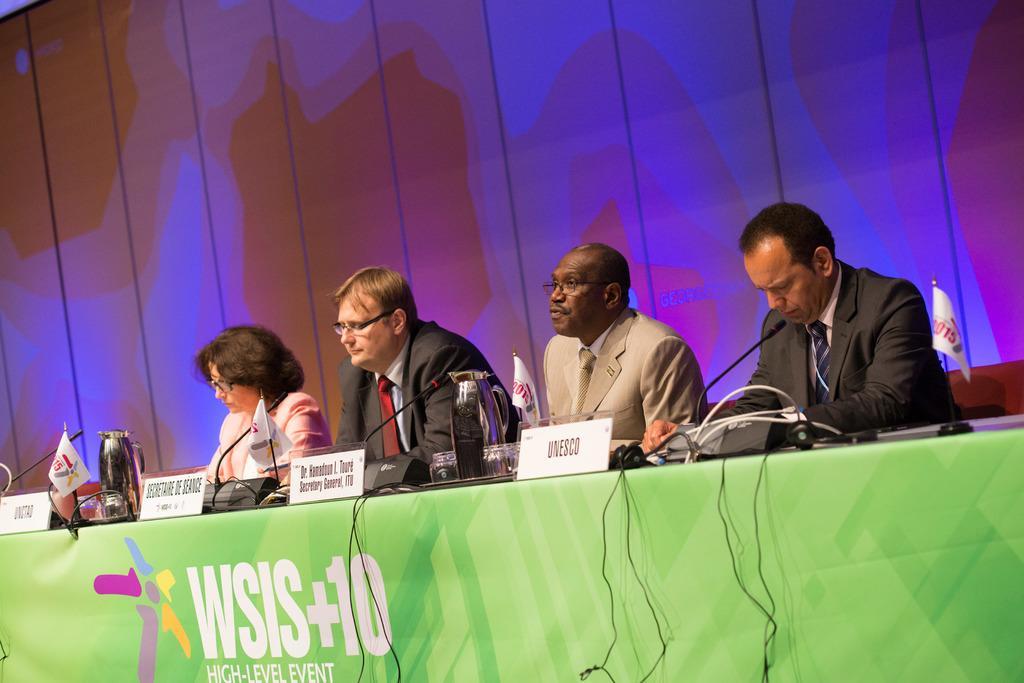Please provide a concise description of this image. In this picture I can see few people seated and I can see few jars and few name boards and microphones and few flags on the table and I can see a banner with some text on it. 